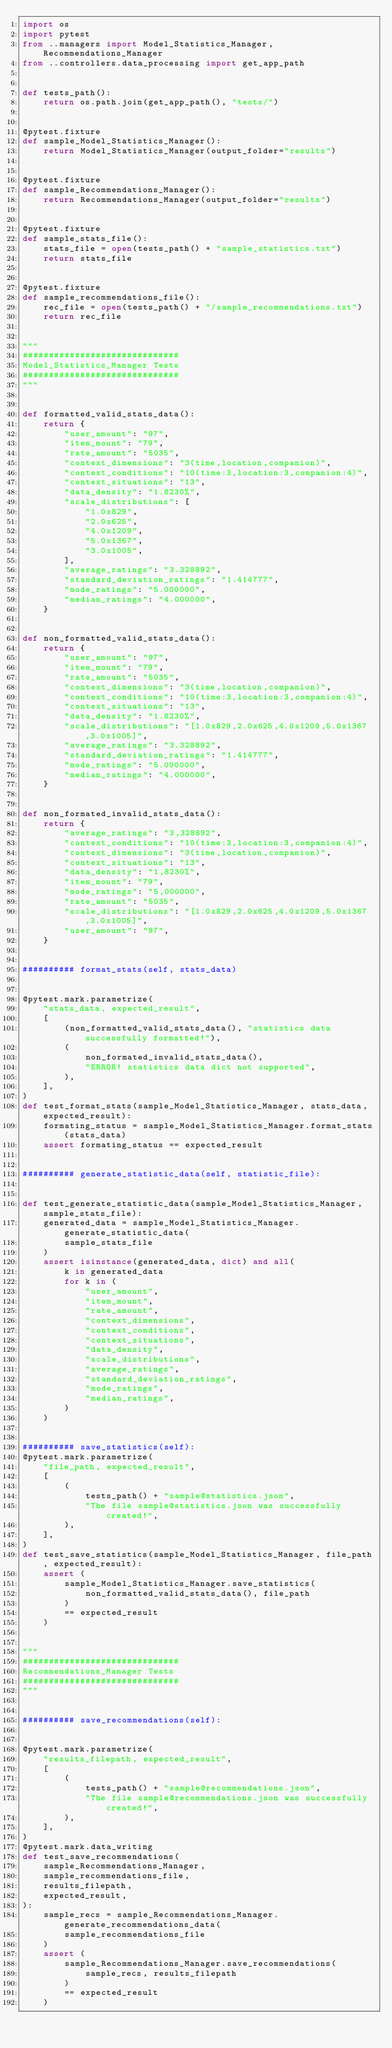Convert code to text. <code><loc_0><loc_0><loc_500><loc_500><_Python_>import os
import pytest
from ..managers import Model_Statistics_Manager, Recommendations_Manager
from ..controllers.data_processing import get_app_path


def tests_path():
    return os.path.join(get_app_path(), "tests/")


@pytest.fixture
def sample_Model_Statistics_Manager():
    return Model_Statistics_Manager(output_folder="results")


@pytest.fixture
def sample_Recommendations_Manager():
    return Recommendations_Manager(output_folder="results")


@pytest.fixture
def sample_stats_file():
    stats_file = open(tests_path() + "sample_statistics.txt")
    return stats_file


@pytest.fixture
def sample_recommendations_file():
    rec_file = open(tests_path() + "/sample_recommendations.txt")
    return rec_file


"""
##############################
Model_Statistics_Manager Tests
##############################
"""


def formatted_valid_stats_data():
    return {
        "user_amount": "97",
        "item_mount": "79",
        "rate_amount": "5035",
        "context_dimensions": "3(time,location,companion)",
        "context_conditions": "10(time:3,location:3,companion:4)",
        "context_situations": "13",
        "data_density": "1.8230%",
        "scale_distributions": [
            "1.0x829",
            "2.0x625",
            "4.0x1209",
            "5.0x1367",
            "3.0x1005",
        ],
        "average_ratings": "3.328892",
        "standard_deviation_ratings": "1.414777",
        "mode_ratings": "5.000000",
        "median_ratings": "4.000000",
    }


def non_formatted_valid_stats_data():
    return {
        "user_amount": "97",
        "item_mount": "79",
        "rate_amount": "5035",
        "context_dimensions": "3(time,location,companion)",
        "context_conditions": "10(time:3,location:3,companion:4)",
        "context_situations": "13",
        "data_density": "1.8230%",
        "scale_distributions": "[1.0x829,2.0x625,4.0x1209,5.0x1367,3.0x1005]",
        "average_ratings": "3.328892",
        "standard_deviation_ratings": "1.414777",
        "mode_ratings": "5.000000",
        "median_ratings": "4.000000",
    }


def non_formated_invalid_stats_data():
    return {
        "average_ratings": "3,328892",
        "context_conditions": "10(time:3,location:3,companion:4)",
        "context_dimensions": "3(time,location,companion)",
        "context_situations": "13",
        "data_density": "1,8230%",
        "item_mount": "79",
        "mode_ratings": "5,000000",
        "rate_amount": "5035",
        "scale_distributions": "[1.0x829,2.0x625,4.0x1209,5.0x1367,3.0x1005]",
        "user_amount": "97",
    }


########## format_stats(self, stats_data)


@pytest.mark.parametrize(
    "stats_data, expected_result",
    [
        (non_formatted_valid_stats_data(), "statistics data successfully formatted!"),
        (
            non_formated_invalid_stats_data(),
            "ERROR! statistics data dict not supported",
        ),
    ],
)
def test_format_stats(sample_Model_Statistics_Manager, stats_data, expected_result):
    formating_status = sample_Model_Statistics_Manager.format_stats(stats_data)
    assert formating_status == expected_result


########## generate_statistic_data(self, statistic_file):


def test_generate_statistic_data(sample_Model_Statistics_Manager, sample_stats_file):
    generated_data = sample_Model_Statistics_Manager.generate_statistic_data(
        sample_stats_file
    )
    assert isinstance(generated_data, dict) and all(
        k in generated_data
        for k in (
            "user_amount",
            "item_mount",
            "rate_amount",
            "context_dimensions",
            "context_conditions",
            "context_situations",
            "data_density",
            "scale_distributions",
            "average_ratings",
            "standard_deviation_ratings",
            "mode_ratings",
            "median_ratings",
        )
    )


########## save_statistics(self):
@pytest.mark.parametrize(
    "file_path, expected_result",
    [
        (
            tests_path() + "sample@statistics.json",
            "The file sample@statistics.json was successfully created!",
        ),
    ],
)
def test_save_statistics(sample_Model_Statistics_Manager, file_path, expected_result):
    assert (
        sample_Model_Statistics_Manager.save_statistics(
            non_formatted_valid_stats_data(), file_path
        )
        == expected_result
    )


"""
##############################
Recommendations_Manager Tests
##############################
"""


########## save_recommendations(self):


@pytest.mark.parametrize(
    "results_filepath, expected_result",
    [
        (
            tests_path() + "sample@recommendations.json",
            "The file sample@recommendations.json was successfully created!",
        ),
    ],
)
@pytest.mark.data_writing
def test_save_recommendations(
    sample_Recommendations_Manager,
    sample_recommendations_file,
    results_filepath,
    expected_result,
):
    sample_recs = sample_Recommendations_Manager.generate_recommendations_data(
        sample_recommendations_file
    )
    assert (
        sample_Recommendations_Manager.save_recommendations(
            sample_recs, results_filepath
        )
        == expected_result
    )
</code> 